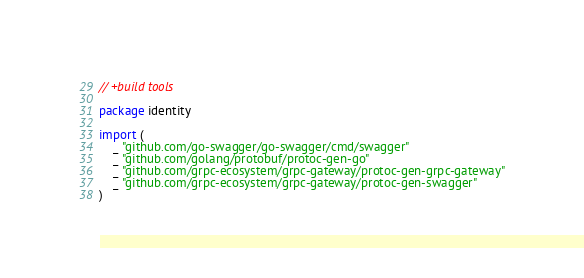<code> <loc_0><loc_0><loc_500><loc_500><_Go_>// +build tools

package identity

import (
	_ "github.com/go-swagger/go-swagger/cmd/swagger"
	_ "github.com/golang/protobuf/protoc-gen-go"
	_ "github.com/grpc-ecosystem/grpc-gateway/protoc-gen-grpc-gateway"
	_ "github.com/grpc-ecosystem/grpc-gateway/protoc-gen-swagger"
)
</code> 